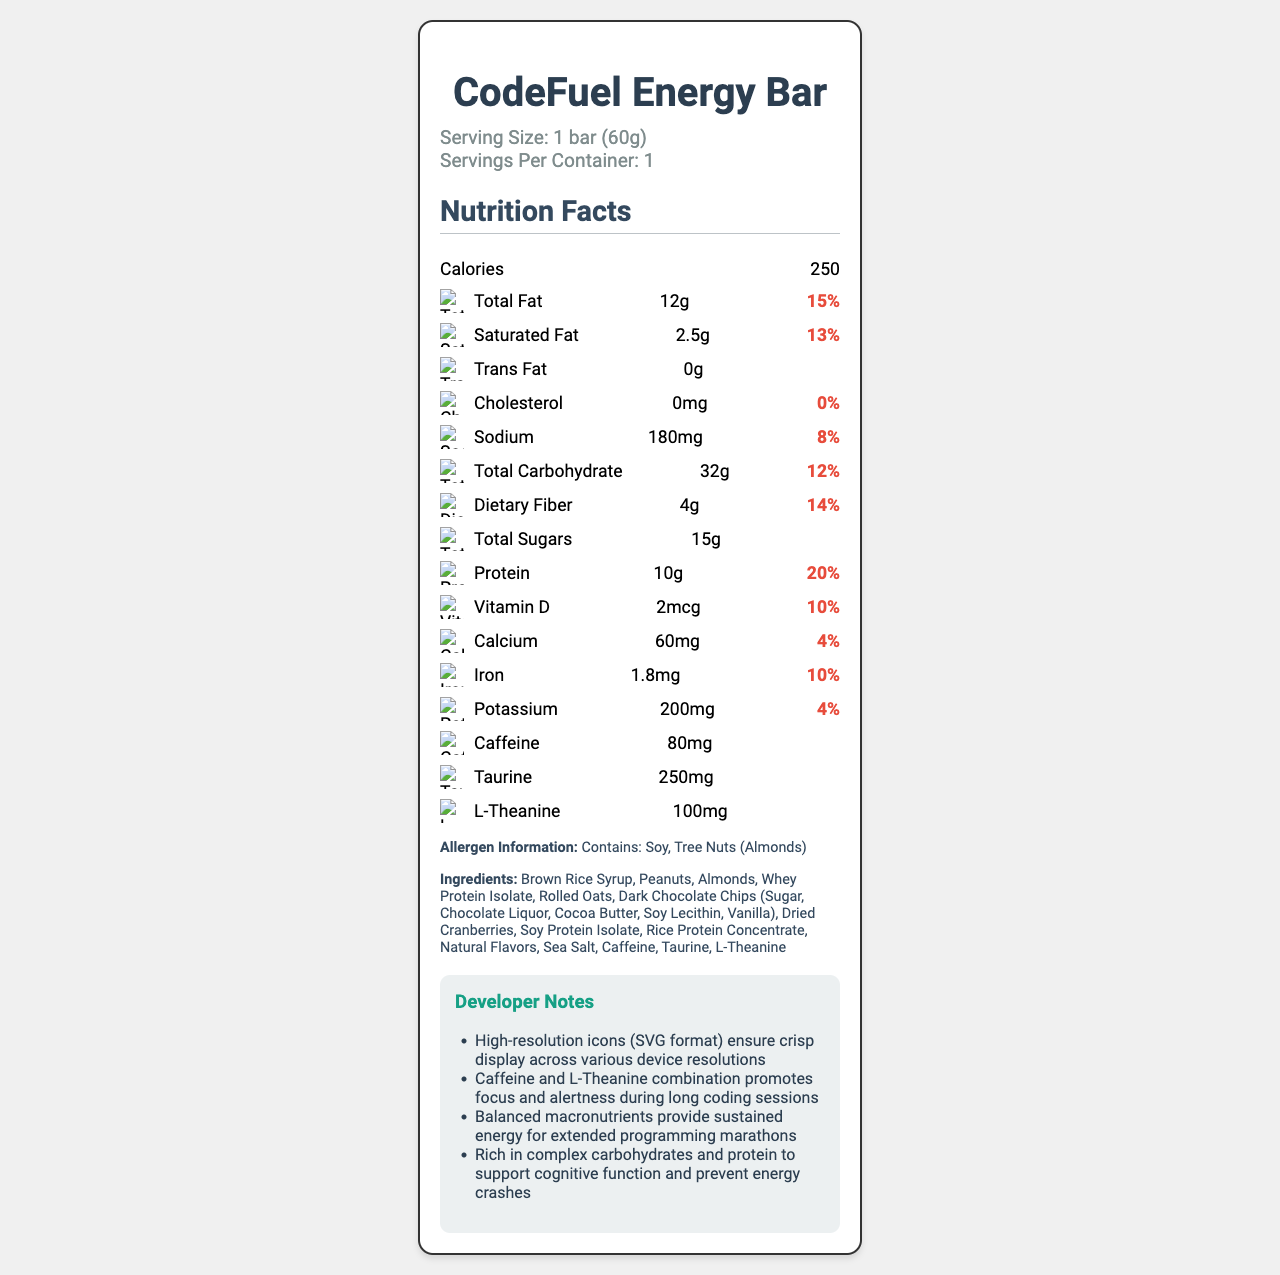what is the serving size? The serving size is clearly stated at the top of the document under the serving information.
Answer: 1 bar (60g) how many calories are in one serving? The document specifies that there are 250 calories per serving.
Answer: 250 what is the amount of Total Fat in the bar? Under the nutrient information row labeled "Total Fat", it is listed as 12g.
Answer: 12g does this energy bar contain cholesterol? The document specifically lists "Cholesterol: 0mg", indicating the energy bar contains no cholesterol.
Answer: No what is the daily value percentage for Dietary Fiber? The daily value percentage for Dietary Fiber is displayed as 14%.
Answer: 14% which nutrient has the highest daily value percentage? Among all the nutrients listed, Protein has the highest daily value percentage with 20%.
Answer: Protein (20%) what icons are used? The developer notes mention that high-resolution icons in SVG format are used for each nutrient to ensure crisp display across various device resolutions.
Answer: SVG icons for each nutrient what allergens are present in the energy bar? The allergen information states that the product contains Soy and Tree Nuts (Almonds).
Answer: Soy, Tree Nuts (Almonds) what is the Sodium content per bar? Under the nutrient information row labeled "Sodium", it is listed as 180mg.
Answer: 180mg which of the following nutrients does not have a daily value percentage listed? A. Total Sugars B. Caffeine C. Taurine D. All of the above Total Sugars, Caffeine, and Taurine do not have daily value percentages listed next to them.
Answer: D. All of the above what are the primary ingredients in the energy bar? A. Whey Protein Isolate B. Almonds C. Brown Rice Syrup D. All of the above The ingredient list mentions Brown Rice Syrup, Almonds, and Whey Protein Isolate among others.
Answer: D. All of the above is there any Vitamin D in the energy bar? The vitamin D content is listed as 2mcg with a daily value of 10%.
Answer: Yes does the energy bar contain caffeine? The nutrient list includes Caffeine, with a content of 80mg.
Answer: Yes summarize the main idea of the document. This document is focused on providing comprehensive nutritional information along with specific ingredients catered to developers for energy and focus during extended coding periods.
Answer: The "CodeFuel Energy Bar" Nutrition Facts document details the nutritional content, ingredients, and developer notes for an energy bar designed for long coding sessions. The bar provides balanced macronutrients and special ingredients like caffeine and L-Theanine to promote alertness and sustained energy. High-resolution SVG icons are used for display compatibility across devices. what is the minimum OS version required for the app compatibility? The minimum OS version is a piece of information typically found in technical specifications, but it's not present or visible in this visual document.
Answer: Cannot be determined how do the SVG icons benefit the display of information on different devices? SVG (Scalable Vector Graphics) icons maintain high resolution and clarity across devices, as mentioned in the developer notes.
Answer: They ensure scalability and a crisp display across devices with various resolutions 